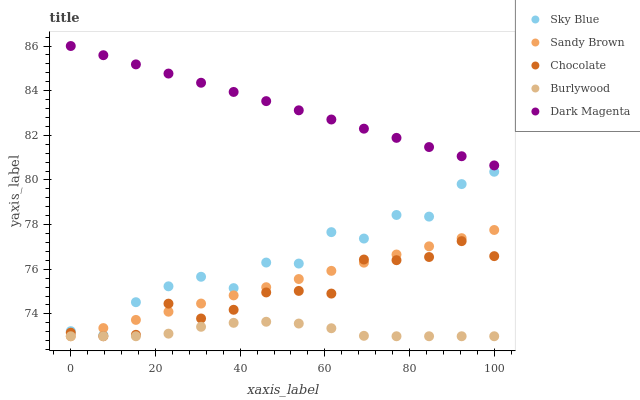Does Burlywood have the minimum area under the curve?
Answer yes or no. Yes. Does Dark Magenta have the maximum area under the curve?
Answer yes or no. Yes. Does Sky Blue have the minimum area under the curve?
Answer yes or no. No. Does Sky Blue have the maximum area under the curve?
Answer yes or no. No. Is Dark Magenta the smoothest?
Answer yes or no. Yes. Is Sky Blue the roughest?
Answer yes or no. Yes. Is Sandy Brown the smoothest?
Answer yes or no. No. Is Sandy Brown the roughest?
Answer yes or no. No. Does Burlywood have the lowest value?
Answer yes or no. Yes. Does Sky Blue have the lowest value?
Answer yes or no. No. Does Dark Magenta have the highest value?
Answer yes or no. Yes. Does Sky Blue have the highest value?
Answer yes or no. No. Is Sandy Brown less than Dark Magenta?
Answer yes or no. Yes. Is Sky Blue greater than Burlywood?
Answer yes or no. Yes. Does Burlywood intersect Sandy Brown?
Answer yes or no. Yes. Is Burlywood less than Sandy Brown?
Answer yes or no. No. Is Burlywood greater than Sandy Brown?
Answer yes or no. No. Does Sandy Brown intersect Dark Magenta?
Answer yes or no. No. 